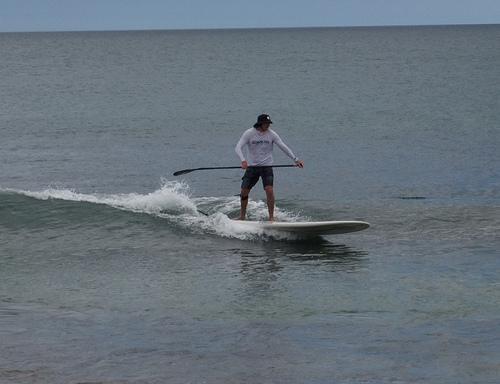How many boards are in the photo?
Give a very brief answer. 1. 